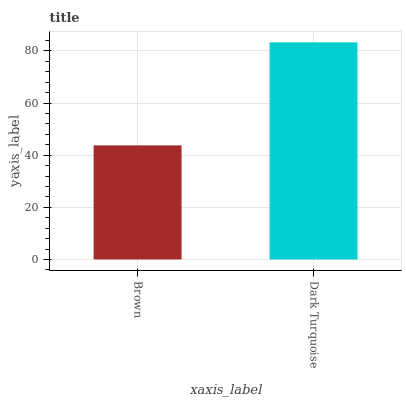Is Dark Turquoise the minimum?
Answer yes or no. No. Is Dark Turquoise greater than Brown?
Answer yes or no. Yes. Is Brown less than Dark Turquoise?
Answer yes or no. Yes. Is Brown greater than Dark Turquoise?
Answer yes or no. No. Is Dark Turquoise less than Brown?
Answer yes or no. No. Is Dark Turquoise the high median?
Answer yes or no. Yes. Is Brown the low median?
Answer yes or no. Yes. Is Brown the high median?
Answer yes or no. No. Is Dark Turquoise the low median?
Answer yes or no. No. 